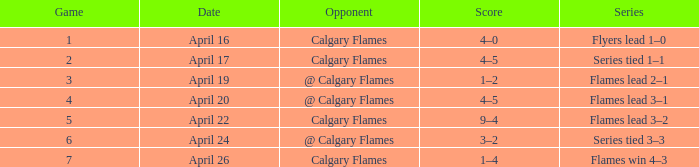When does a game have fewer than 4, and an opponent like calgary flames, and a tally of 4-5? April 17. 